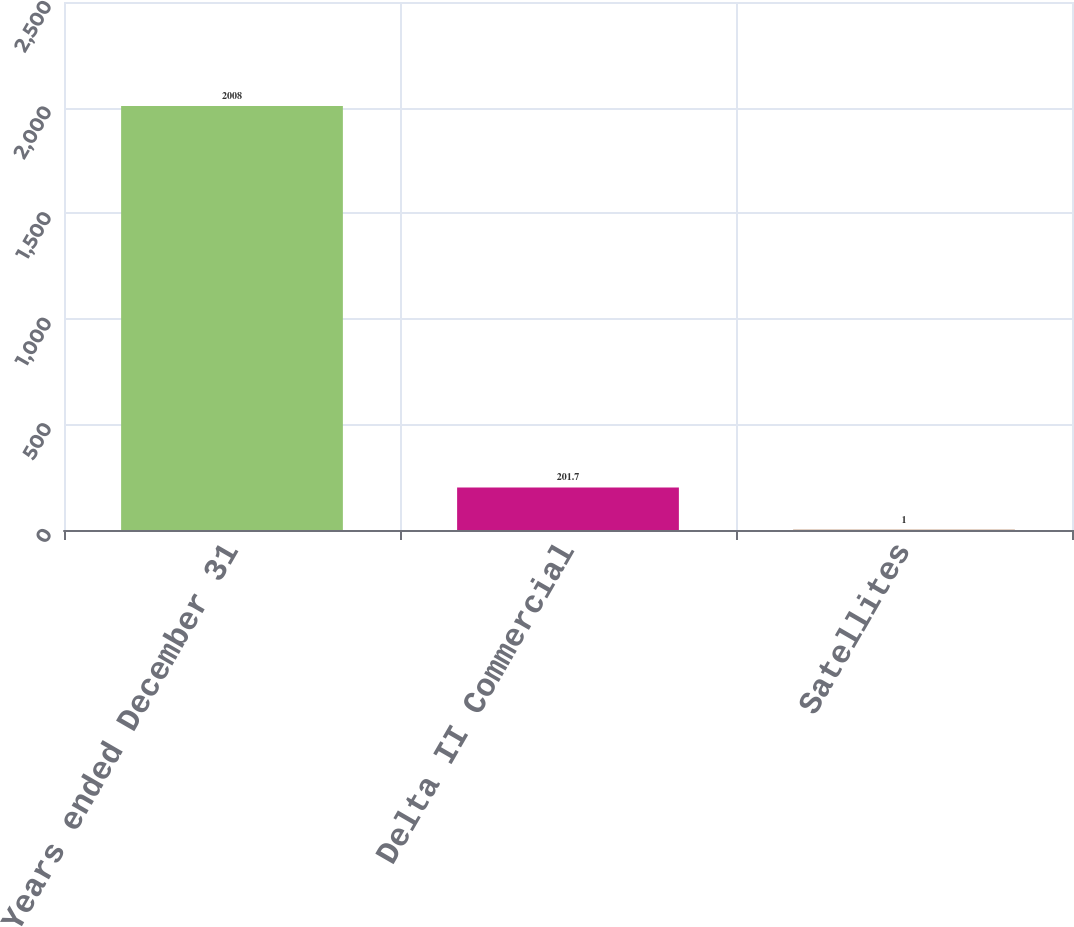Convert chart to OTSL. <chart><loc_0><loc_0><loc_500><loc_500><bar_chart><fcel>Years ended December 31<fcel>Delta II Commercial<fcel>Satellites<nl><fcel>2008<fcel>201.7<fcel>1<nl></chart> 